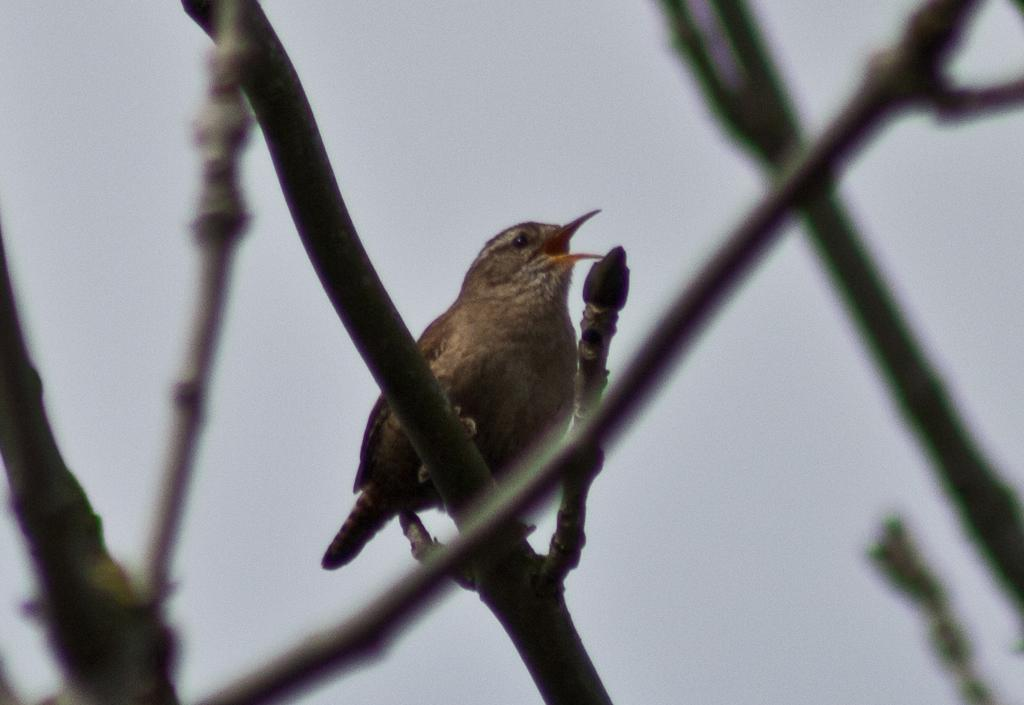What type of animal is in the image? There is a bird in the image. Where is the bird located? The bird is standing on a branch. What can be seen behind the bird? The sky is visible behind the bird. What type of whistle is the bird holding in its beak in the image? There is no whistle present in the image; the bird is standing on a branch with nothing in its beak. 